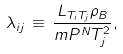<formula> <loc_0><loc_0><loc_500><loc_500>\lambda _ { i j } \, \equiv \, \frac { L _ { T _ { i } T _ { j } } \rho _ { B } } { m P ^ { N } T _ { j } ^ { 2 } } ,</formula> 